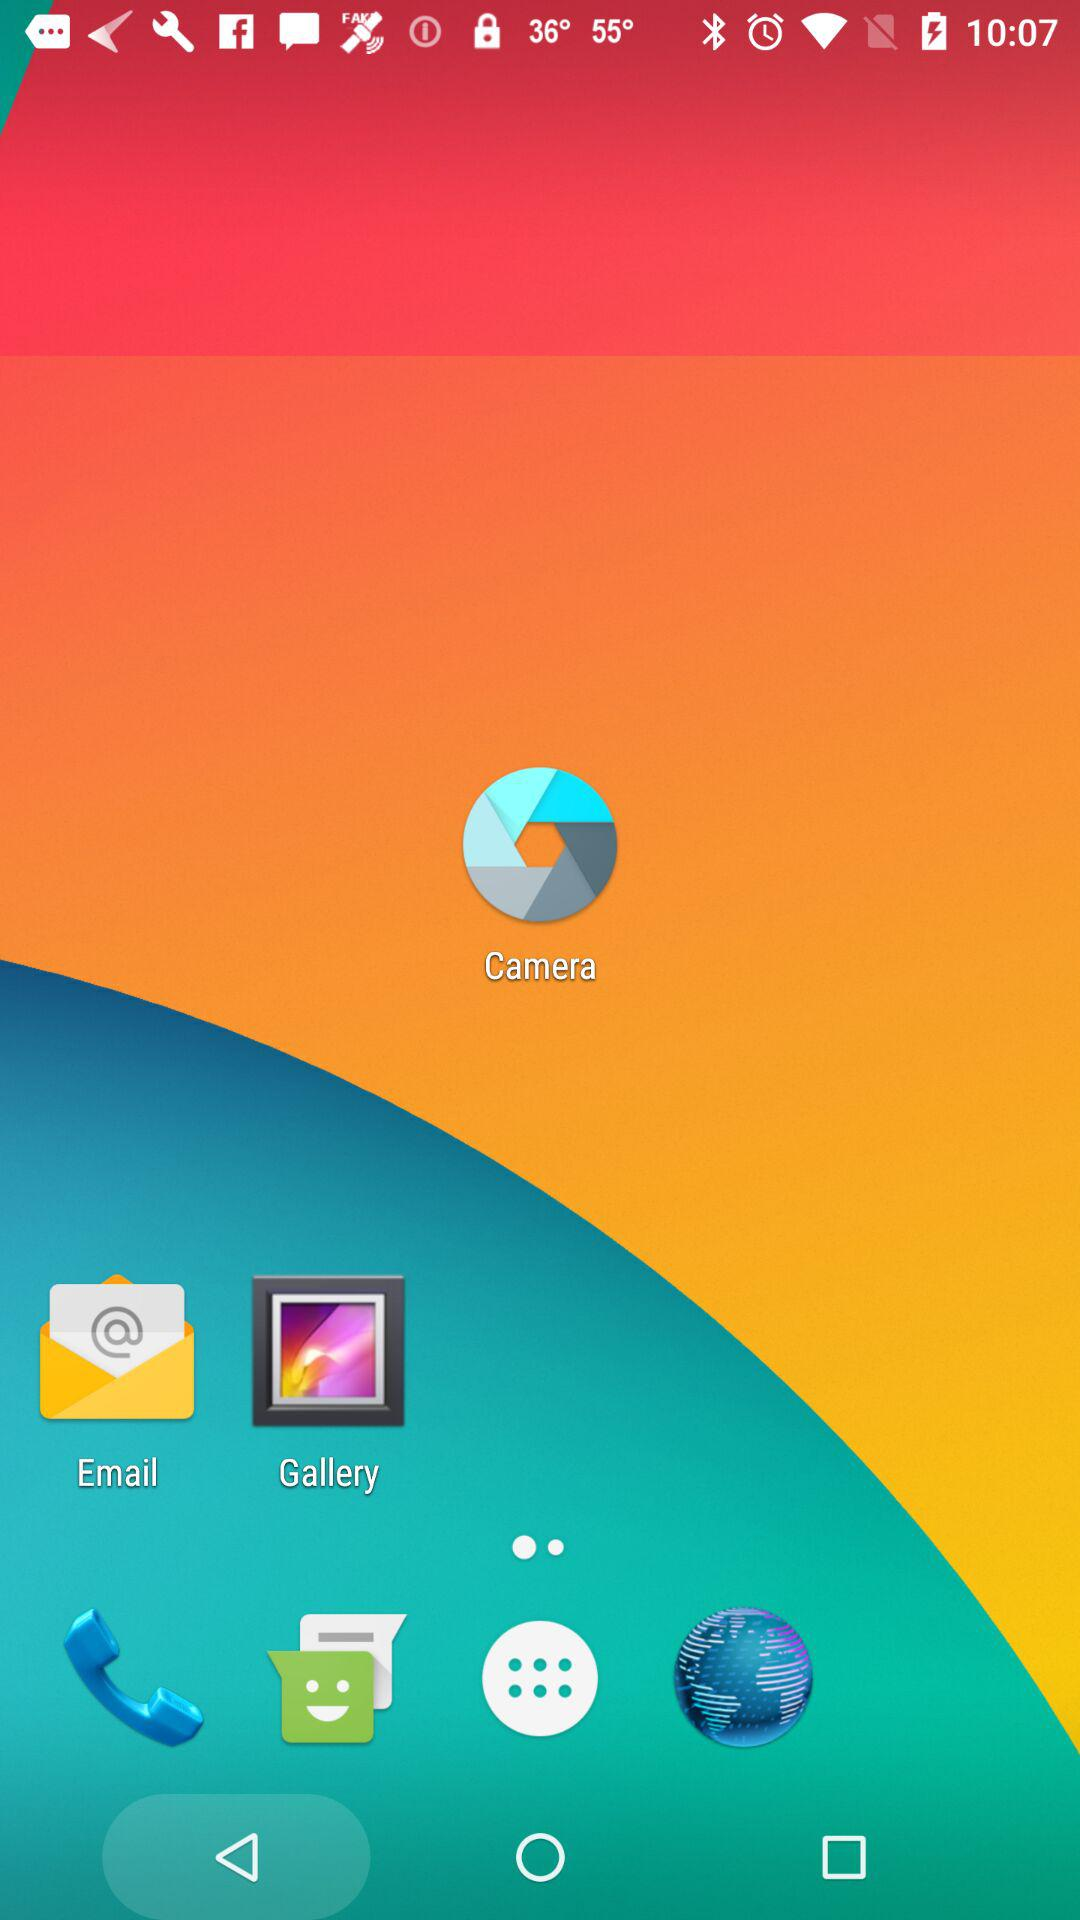What is the application name? The application name is "Find People Search". 